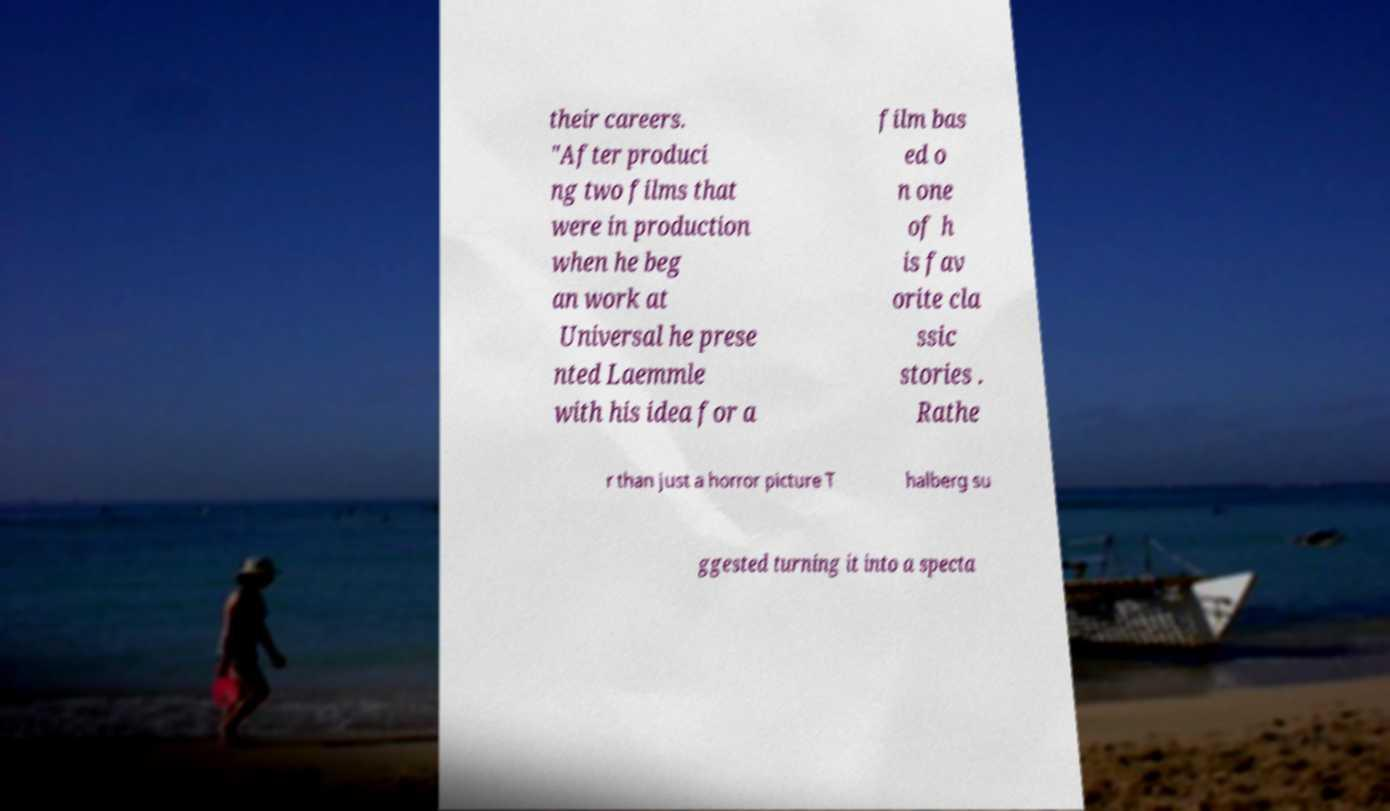Can you accurately transcribe the text from the provided image for me? their careers. "After produci ng two films that were in production when he beg an work at Universal he prese nted Laemmle with his idea for a film bas ed o n one of h is fav orite cla ssic stories . Rathe r than just a horror picture T halberg su ggested turning it into a specta 